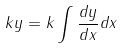Convert formula to latex. <formula><loc_0><loc_0><loc_500><loc_500>k y = k \int \frac { d y } { d x } d x</formula> 